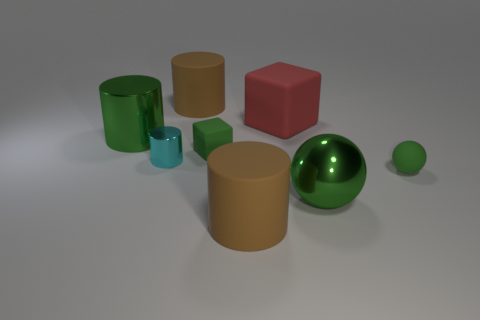There is a rubber sphere that is the same color as the metal sphere; what size is it?
Provide a short and direct response. Small. Does the cyan object have the same size as the sphere that is on the right side of the large metallic ball?
Give a very brief answer. Yes. What number of balls are either brown things or big matte objects?
Provide a succinct answer. 0. What is the size of the cyan thing that is made of the same material as the green cylinder?
Your answer should be compact. Small. Is the size of the rubber block behind the green cube the same as the green rubber cube right of the cyan thing?
Your answer should be very brief. No. How many objects are large brown blocks or large blocks?
Offer a very short reply. 1. What shape is the big red matte object?
Your answer should be very brief. Cube. The green rubber object that is the same shape as the large red rubber object is what size?
Your response must be concise. Small. There is a matte block that is to the left of the large matte cylinder right of the green matte block; what is its size?
Your response must be concise. Small. Is the number of brown objects behind the red block the same as the number of yellow cubes?
Your answer should be compact. No. 